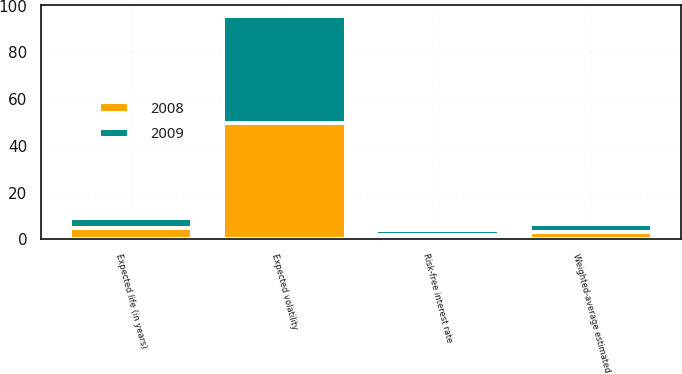<chart> <loc_0><loc_0><loc_500><loc_500><stacked_bar_chart><ecel><fcel>Risk-free interest rate<fcel>Expected volatility<fcel>Expected life (in years)<fcel>Weighted-average estimated<nl><fcel>2008<fcel>1.75<fcel>49.96<fcel>4.72<fcel>3.31<nl><fcel>2009<fcel>2.18<fcel>45.63<fcel>4.54<fcel>3.38<nl></chart> 